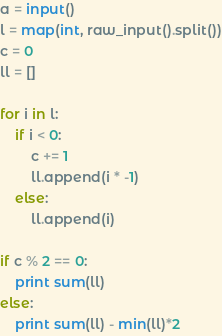<code> <loc_0><loc_0><loc_500><loc_500><_Python_>a = input()
l = map(int, raw_input().split())
c = 0
ll = []

for i in l:
	if i < 0:
		c += 1
		ll.append(i * -1)
	else:
		ll.append(i)

if c % 2 == 0:
	print sum(ll)
else:
	print sum(ll) - min(ll)*2</code> 